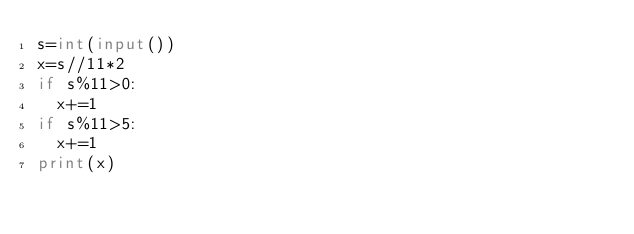Convert code to text. <code><loc_0><loc_0><loc_500><loc_500><_Python_>s=int(input())
x=s//11*2
if s%11>0:
  x+=1
if s%11>5:
  x+=1
print(x)</code> 